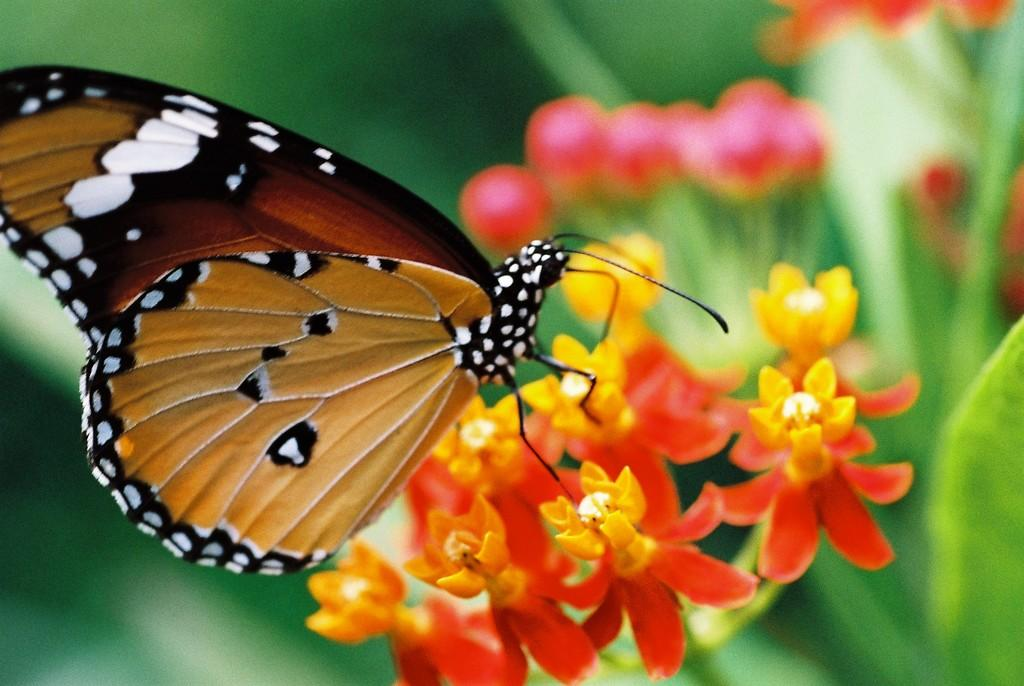What is the main subject of the image? There is a butterfly in the image. Where is the butterfly located in the image? The butterfly is on a flower. Can you touch the lake in the image? There is no lake present in the image, so it cannot be touched. 